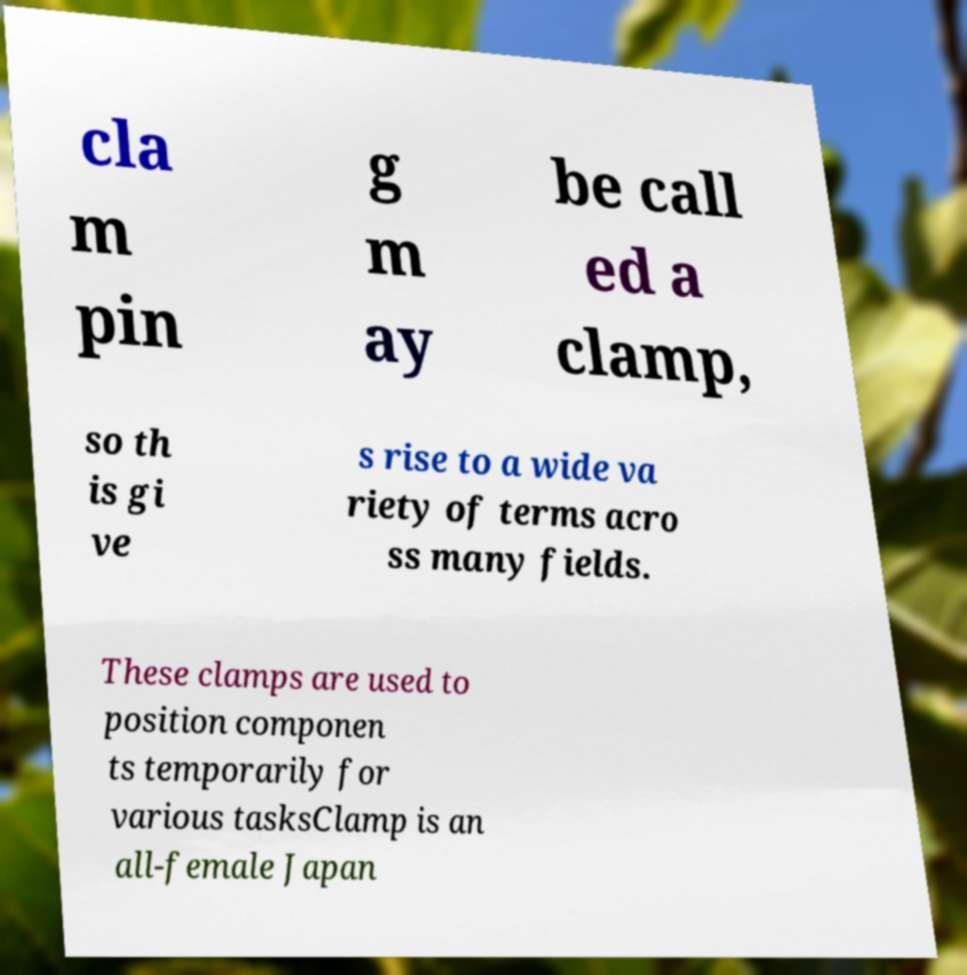What messages or text are displayed in this image? I need them in a readable, typed format. cla m pin g m ay be call ed a clamp, so th is gi ve s rise to a wide va riety of terms acro ss many fields. These clamps are used to position componen ts temporarily for various tasksClamp is an all-female Japan 